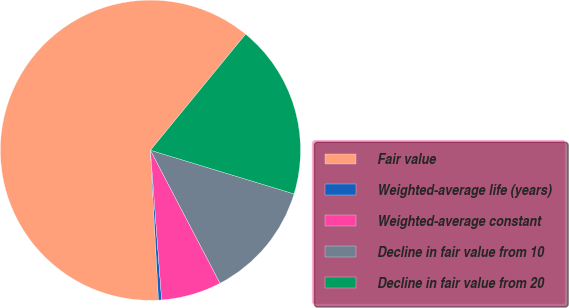<chart> <loc_0><loc_0><loc_500><loc_500><pie_chart><fcel>Fair value<fcel>Weighted-average life (years)<fcel>Weighted-average constant<fcel>Decline in fair value from 10<fcel>Decline in fair value from 20<nl><fcel>61.78%<fcel>0.34%<fcel>6.48%<fcel>12.63%<fcel>18.77%<nl></chart> 